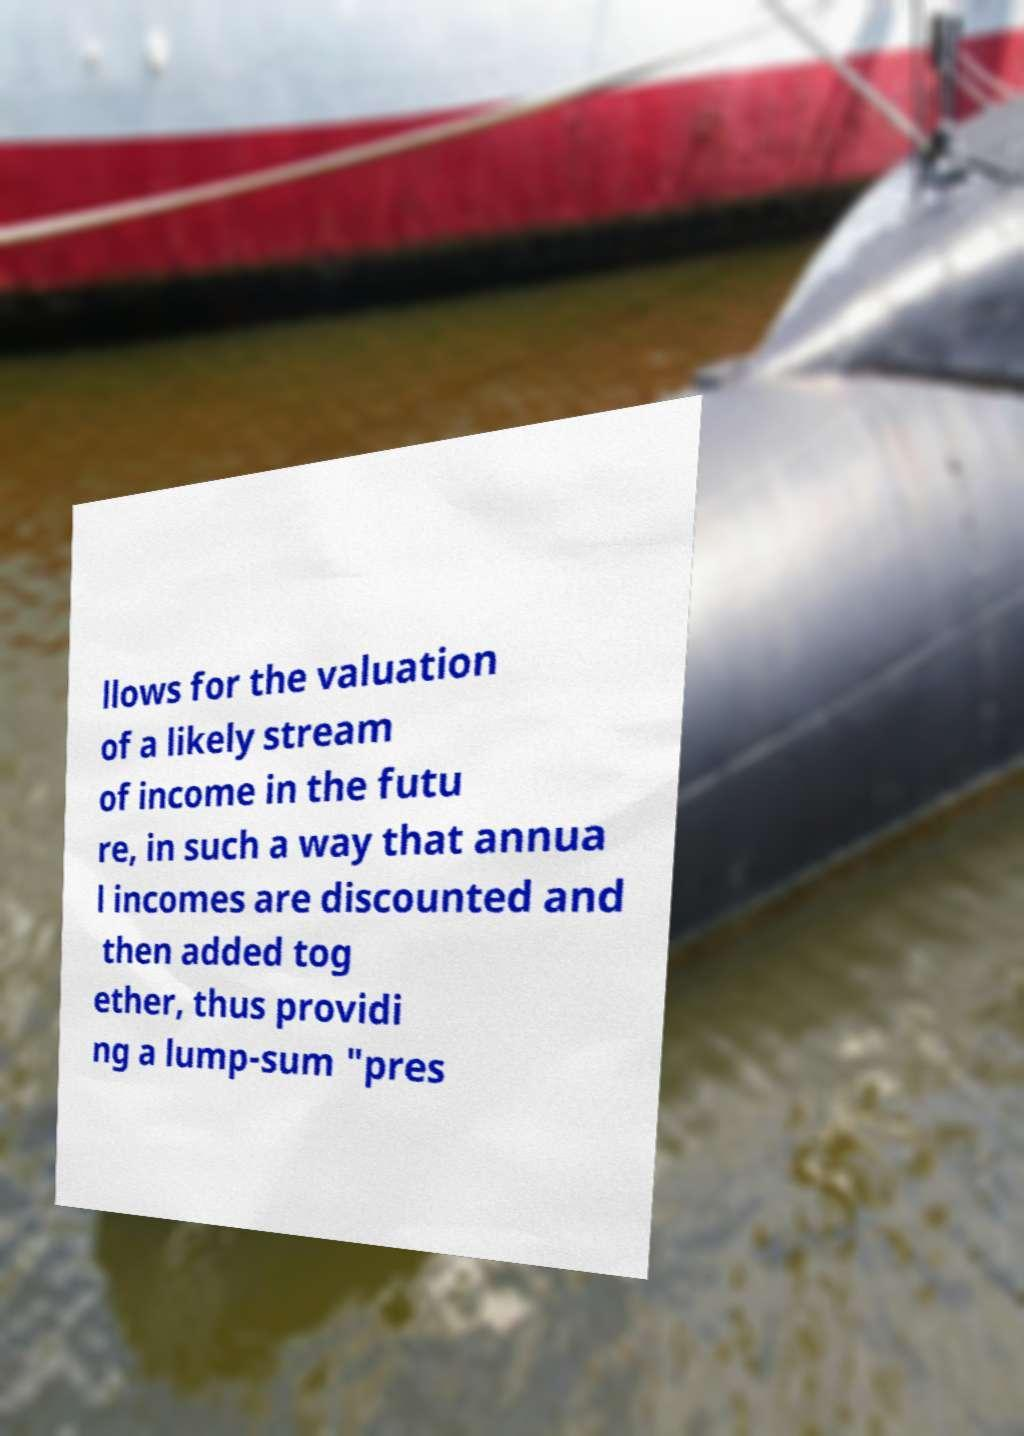Please read and relay the text visible in this image. What does it say? llows for the valuation of a likely stream of income in the futu re, in such a way that annua l incomes are discounted and then added tog ether, thus providi ng a lump-sum "pres 